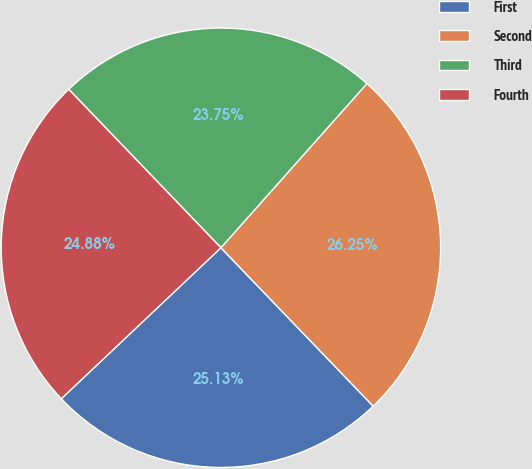Convert chart. <chart><loc_0><loc_0><loc_500><loc_500><pie_chart><fcel>First<fcel>Second<fcel>Third<fcel>Fourth<nl><fcel>25.13%<fcel>26.25%<fcel>23.75%<fcel>24.88%<nl></chart> 